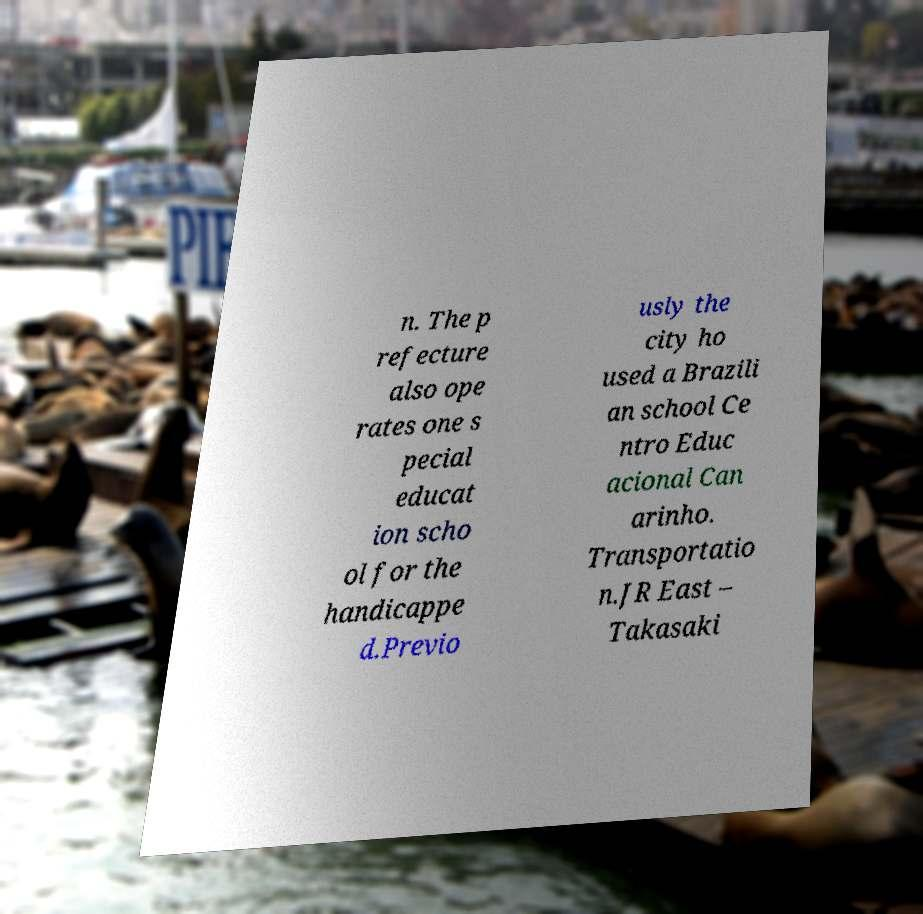Could you assist in decoding the text presented in this image and type it out clearly? n. The p refecture also ope rates one s pecial educat ion scho ol for the handicappe d.Previo usly the city ho used a Brazili an school Ce ntro Educ acional Can arinho. Transportatio n.JR East – Takasaki 